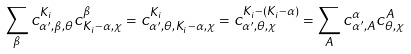Convert formula to latex. <formula><loc_0><loc_0><loc_500><loc_500>\sum _ { \beta } c _ { \alpha ^ { \prime } , \beta , \theta } ^ { K _ { i } } c _ { K _ { i } - \alpha , \chi } ^ { \beta } = c _ { \alpha ^ { \prime } , \theta , K _ { i } - \alpha , \chi } ^ { K _ { i } } = c _ { \alpha ^ { \prime } , \theta , \chi } ^ { K _ { i } - ( K _ { i } - \alpha ) } = \sum _ { A } c _ { \alpha ^ { \prime } , A } ^ { \alpha } c _ { \theta , \chi } ^ { A }</formula> 